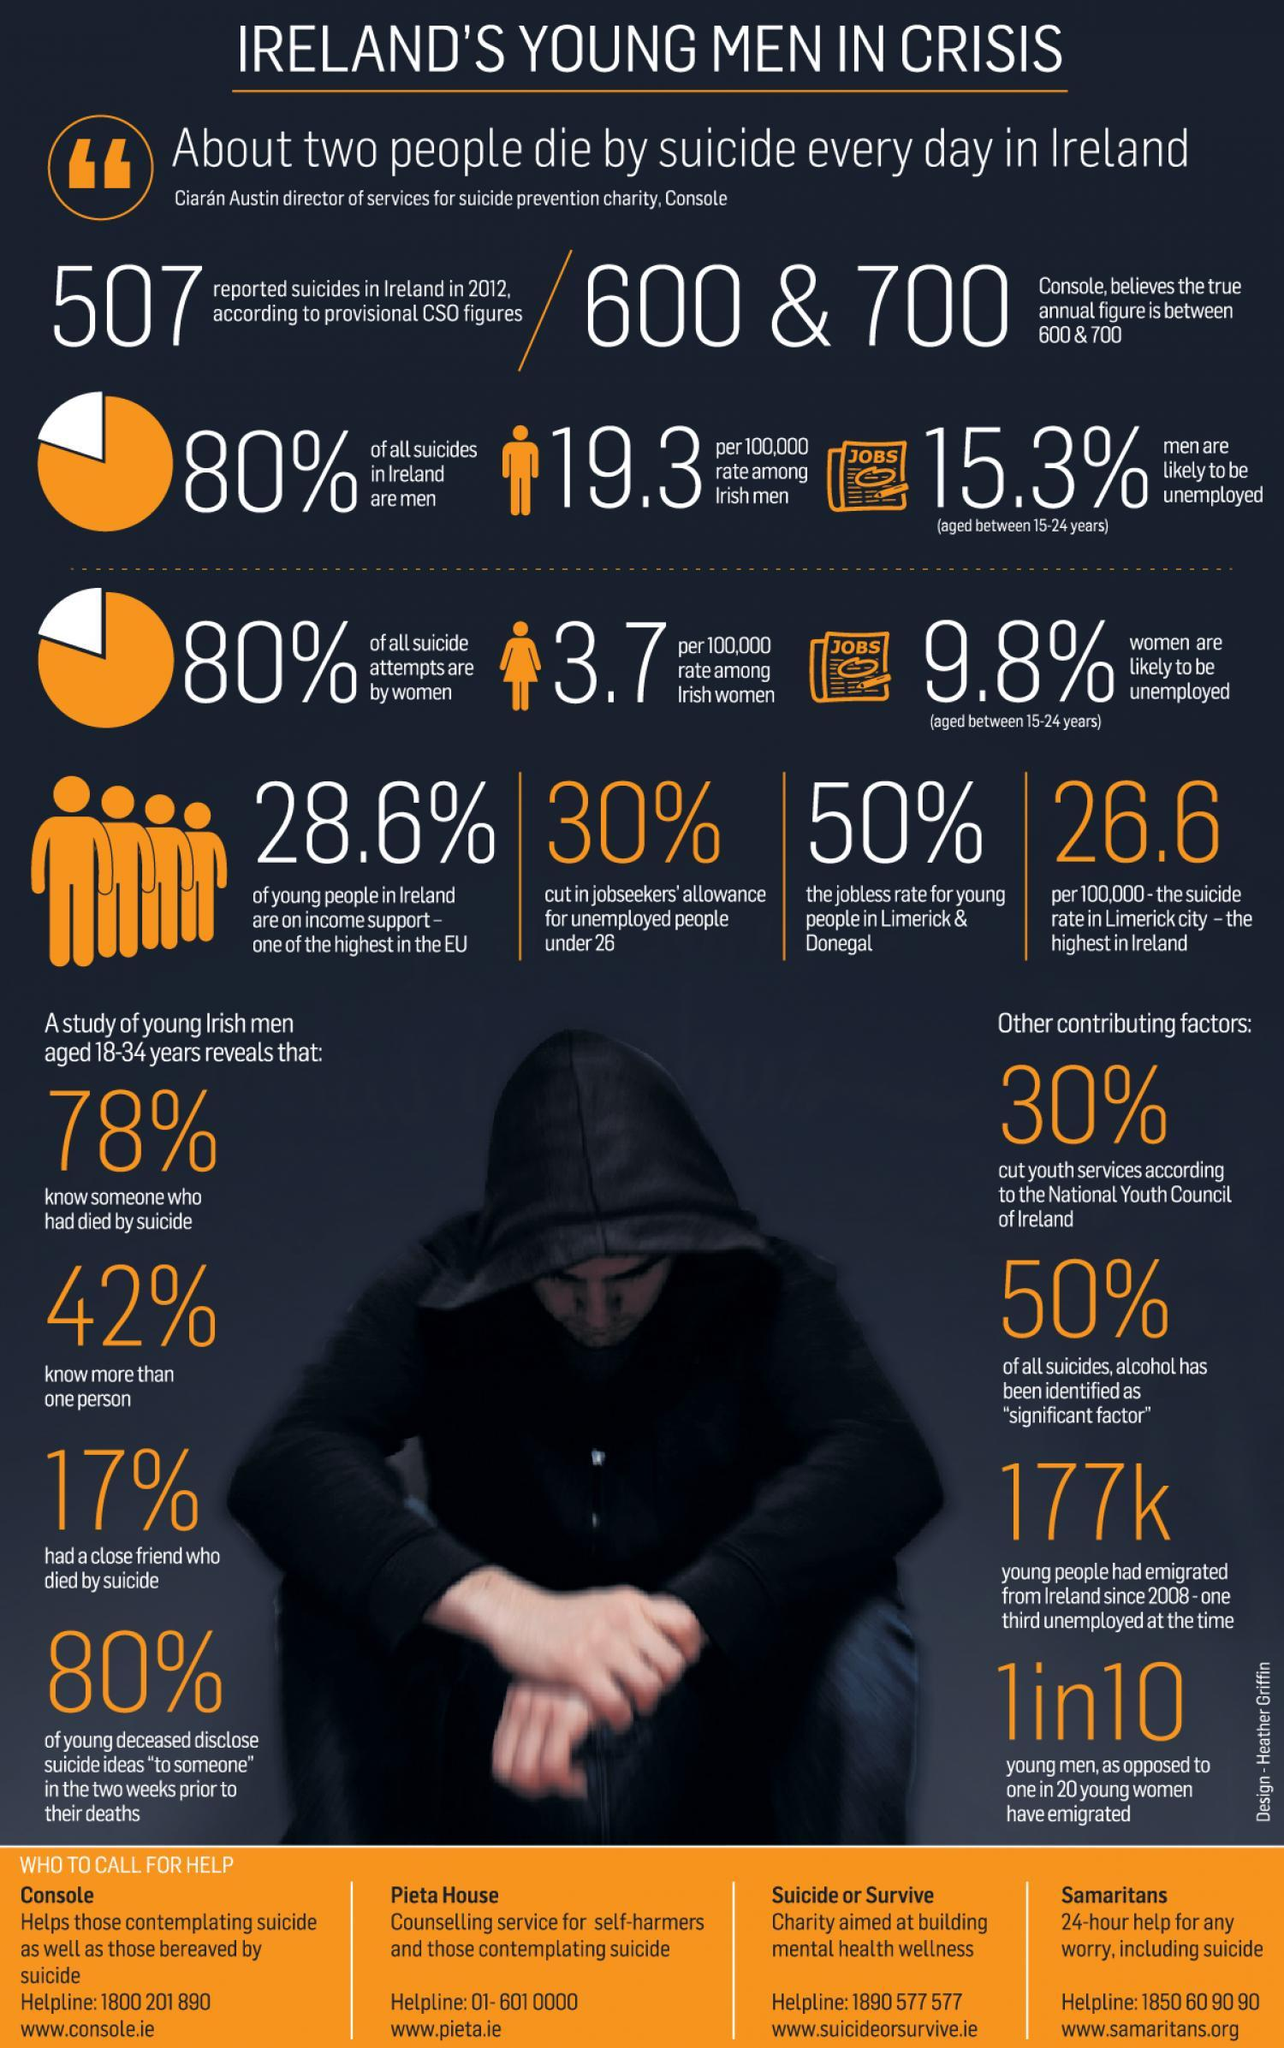What is the jobless rate for young people in Limerick & Donegal?
Answer the question with a short phrase. 50% What is the percentage cut in jobseekers' allowance for unemployed people under 26 in Ireland? 30% What percent of the young Irish men aged 18-34 years know more than one person who died by suicide? 42% In what percentage of all suicides in Ireland, alcohol has been identified as "significant factor"? 50% What percent of the young Irish men aged 18-34 years had a close friend who died by suicide? 17% What is the percentage cut in the youth services according to the National Youth Council of Ireland? 30% What percent of all suicides in Ireland are men? 80% What is the number of young people who had emigrated from Ireland since 2008? 177k What is the suicide rate per million population in the Limerick city of Ireland? 26.6 Which city in Ireland has reported the highest suicide rate? Limerick city 